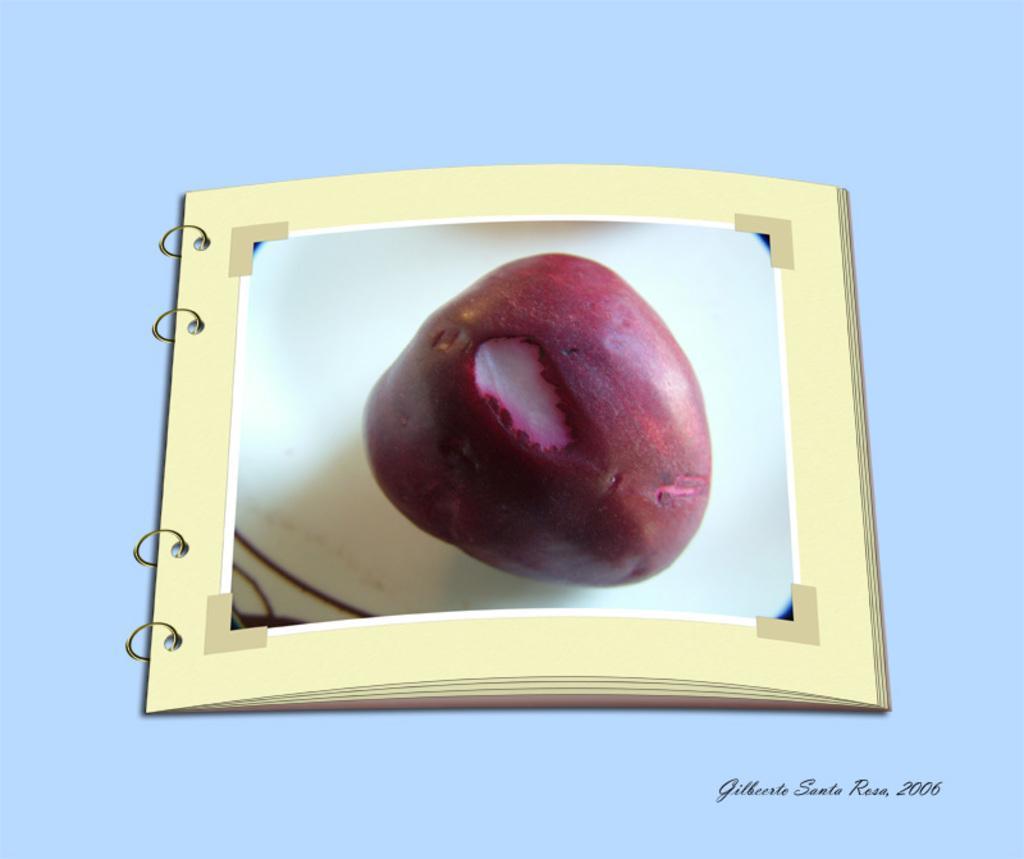Can you describe this image briefly? In this image we can see the picture of a fruit. 